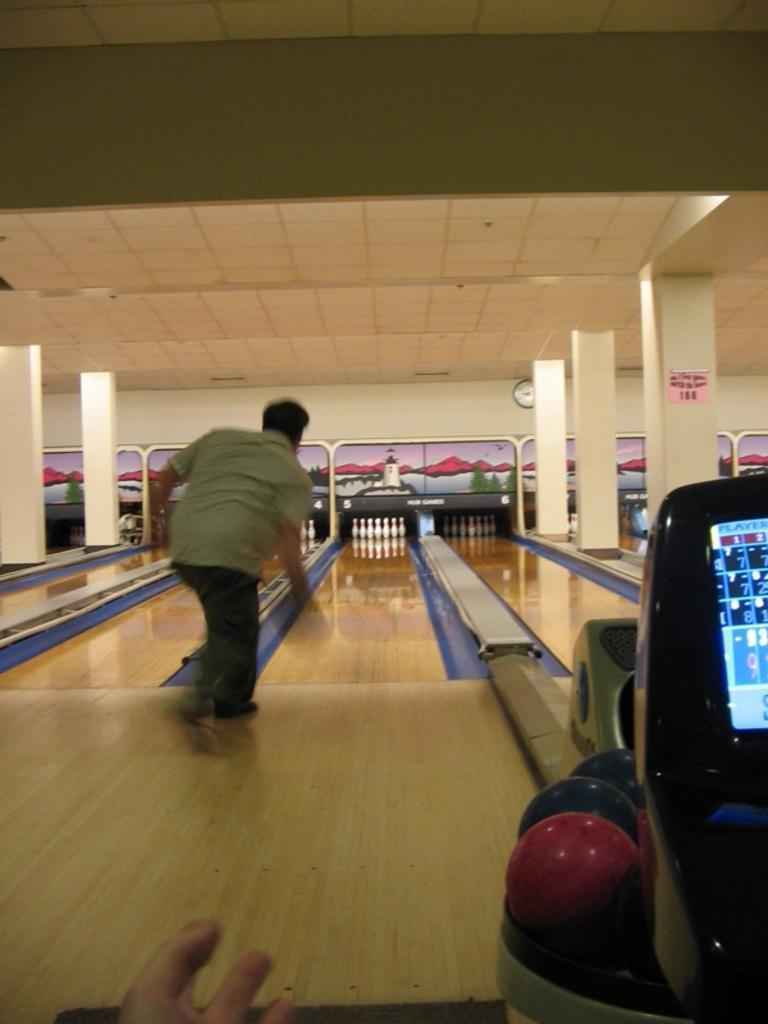Who is the main subject in the image? There is a man in the image. What is the man doing in the image? The man is playing a bowling game. What can be seen on the wall in the image? There is a clock on the wall in the image. What objects are related to the bowling game in the image? There are balls visible in the image. What type of equipment is present in the image? There is a machine in the image. Can you see the man flying in the image? No, the man is not flying in the image; he is playing a bowling game. Is there a throne present in the image? No, there is no throne present in the image. 